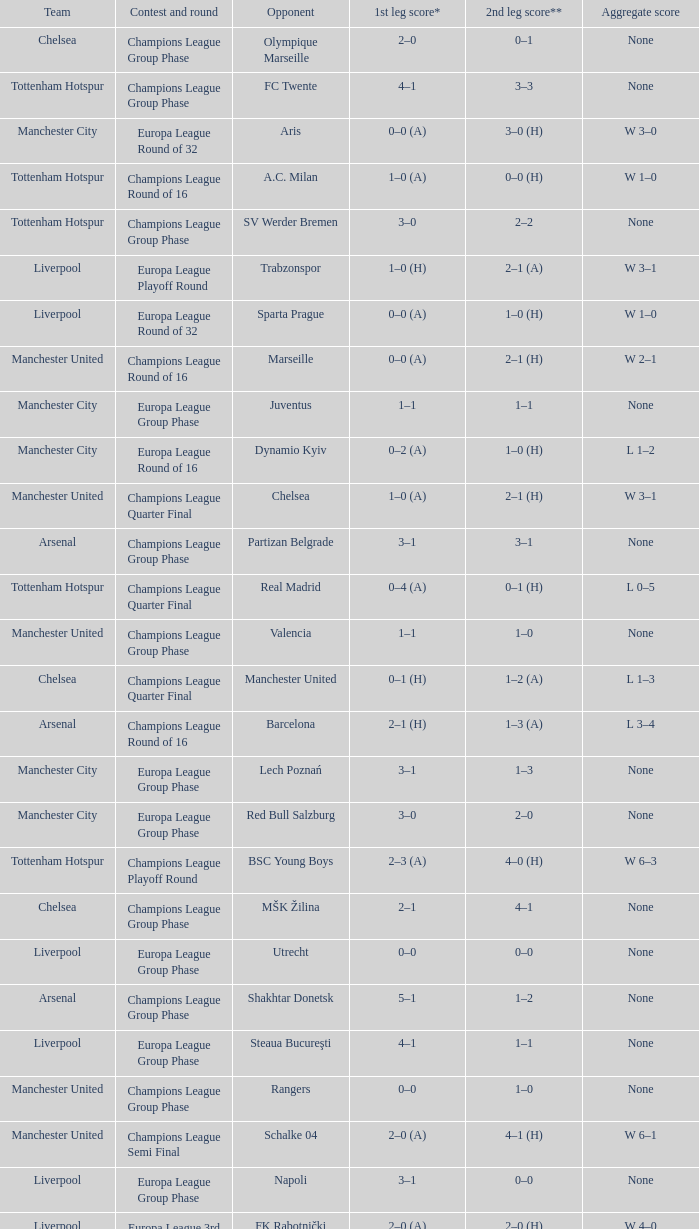What was the score between Marseille and Manchester United on the second leg of the Champions League Round of 16? 2–1 (H). 